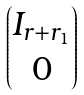Convert formula to latex. <formula><loc_0><loc_0><loc_500><loc_500>\begin{pmatrix} I _ { r + r _ { 1 } } \\ 0 \end{pmatrix}</formula> 